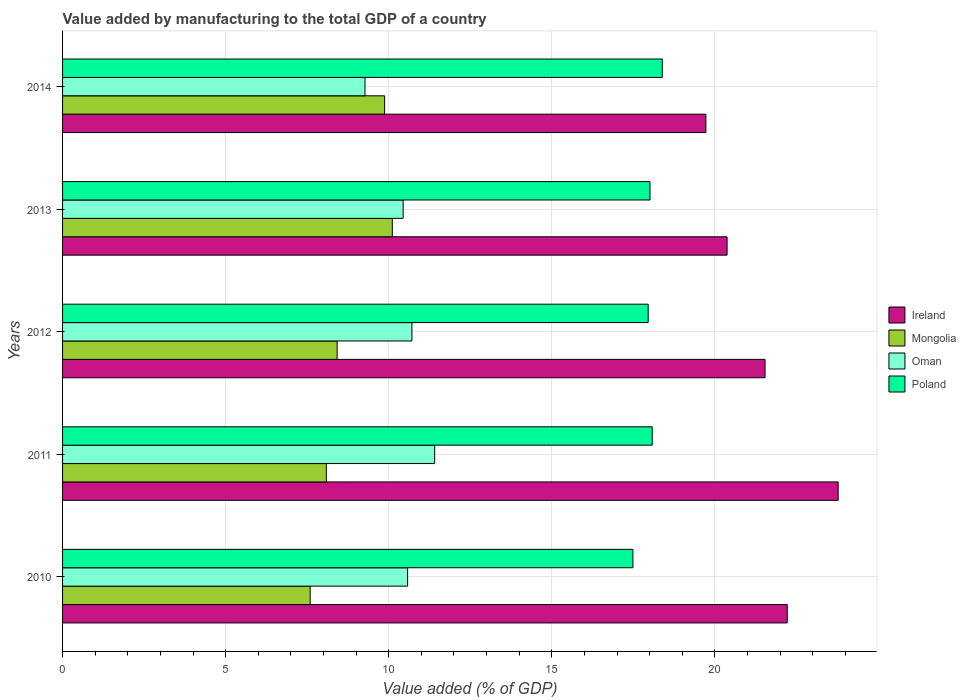How many different coloured bars are there?
Offer a very short reply. 4. How many groups of bars are there?
Keep it short and to the point. 5. Are the number of bars per tick equal to the number of legend labels?
Provide a short and direct response. Yes. Are the number of bars on each tick of the Y-axis equal?
Provide a succinct answer. Yes. How many bars are there on the 5th tick from the top?
Provide a succinct answer. 4. How many bars are there on the 5th tick from the bottom?
Give a very brief answer. 4. What is the value added by manufacturing to the total GDP in Oman in 2014?
Your answer should be very brief. 9.27. Across all years, what is the maximum value added by manufacturing to the total GDP in Oman?
Provide a succinct answer. 11.41. Across all years, what is the minimum value added by manufacturing to the total GDP in Ireland?
Your answer should be compact. 19.72. In which year was the value added by manufacturing to the total GDP in Ireland maximum?
Ensure brevity in your answer.  2011. What is the total value added by manufacturing to the total GDP in Oman in the graph?
Give a very brief answer. 52.41. What is the difference between the value added by manufacturing to the total GDP in Mongolia in 2012 and that in 2013?
Provide a short and direct response. -1.69. What is the difference between the value added by manufacturing to the total GDP in Mongolia in 2014 and the value added by manufacturing to the total GDP in Oman in 2013?
Make the answer very short. -0.57. What is the average value added by manufacturing to the total GDP in Poland per year?
Your answer should be compact. 17.98. In the year 2012, what is the difference between the value added by manufacturing to the total GDP in Poland and value added by manufacturing to the total GDP in Ireland?
Your response must be concise. -3.58. In how many years, is the value added by manufacturing to the total GDP in Oman greater than 15 %?
Offer a terse response. 0. What is the ratio of the value added by manufacturing to the total GDP in Oman in 2012 to that in 2014?
Offer a very short reply. 1.16. Is the difference between the value added by manufacturing to the total GDP in Poland in 2012 and 2013 greater than the difference between the value added by manufacturing to the total GDP in Ireland in 2012 and 2013?
Keep it short and to the point. No. What is the difference between the highest and the second highest value added by manufacturing to the total GDP in Oman?
Give a very brief answer. 0.7. What is the difference between the highest and the lowest value added by manufacturing to the total GDP in Ireland?
Provide a short and direct response. 4.06. Is the sum of the value added by manufacturing to the total GDP in Mongolia in 2012 and 2013 greater than the maximum value added by manufacturing to the total GDP in Ireland across all years?
Your answer should be very brief. No. Is it the case that in every year, the sum of the value added by manufacturing to the total GDP in Mongolia and value added by manufacturing to the total GDP in Poland is greater than the sum of value added by manufacturing to the total GDP in Oman and value added by manufacturing to the total GDP in Ireland?
Make the answer very short. No. What does the 3rd bar from the top in 2013 represents?
Give a very brief answer. Mongolia. What does the 1st bar from the bottom in 2014 represents?
Your answer should be very brief. Ireland. Is it the case that in every year, the sum of the value added by manufacturing to the total GDP in Poland and value added by manufacturing to the total GDP in Oman is greater than the value added by manufacturing to the total GDP in Ireland?
Offer a terse response. Yes. How many bars are there?
Offer a terse response. 20. Are the values on the major ticks of X-axis written in scientific E-notation?
Keep it short and to the point. No. How are the legend labels stacked?
Make the answer very short. Vertical. What is the title of the graph?
Your answer should be compact. Value added by manufacturing to the total GDP of a country. Does "Costa Rica" appear as one of the legend labels in the graph?
Keep it short and to the point. No. What is the label or title of the X-axis?
Make the answer very short. Value added (% of GDP). What is the Value added (% of GDP) in Ireland in 2010?
Ensure brevity in your answer.  22.22. What is the Value added (% of GDP) in Mongolia in 2010?
Offer a terse response. 7.59. What is the Value added (% of GDP) of Oman in 2010?
Make the answer very short. 10.58. What is the Value added (% of GDP) of Poland in 2010?
Your answer should be compact. 17.49. What is the Value added (% of GDP) of Ireland in 2011?
Provide a short and direct response. 23.78. What is the Value added (% of GDP) of Mongolia in 2011?
Ensure brevity in your answer.  8.09. What is the Value added (% of GDP) of Oman in 2011?
Ensure brevity in your answer.  11.41. What is the Value added (% of GDP) in Poland in 2011?
Your answer should be compact. 18.08. What is the Value added (% of GDP) of Ireland in 2012?
Give a very brief answer. 21.54. What is the Value added (% of GDP) of Mongolia in 2012?
Make the answer very short. 8.42. What is the Value added (% of GDP) in Oman in 2012?
Provide a succinct answer. 10.71. What is the Value added (% of GDP) in Poland in 2012?
Make the answer very short. 17.95. What is the Value added (% of GDP) of Ireland in 2013?
Provide a succinct answer. 20.37. What is the Value added (% of GDP) in Mongolia in 2013?
Provide a succinct answer. 10.11. What is the Value added (% of GDP) of Oman in 2013?
Provide a short and direct response. 10.44. What is the Value added (% of GDP) in Poland in 2013?
Give a very brief answer. 18.01. What is the Value added (% of GDP) of Ireland in 2014?
Offer a terse response. 19.72. What is the Value added (% of GDP) of Mongolia in 2014?
Your answer should be compact. 9.87. What is the Value added (% of GDP) in Oman in 2014?
Offer a terse response. 9.27. What is the Value added (% of GDP) of Poland in 2014?
Your response must be concise. 18.39. Across all years, what is the maximum Value added (% of GDP) in Ireland?
Provide a short and direct response. 23.78. Across all years, what is the maximum Value added (% of GDP) in Mongolia?
Keep it short and to the point. 10.11. Across all years, what is the maximum Value added (% of GDP) of Oman?
Ensure brevity in your answer.  11.41. Across all years, what is the maximum Value added (% of GDP) in Poland?
Your answer should be compact. 18.39. Across all years, what is the minimum Value added (% of GDP) in Ireland?
Provide a short and direct response. 19.72. Across all years, what is the minimum Value added (% of GDP) in Mongolia?
Provide a succinct answer. 7.59. Across all years, what is the minimum Value added (% of GDP) of Oman?
Offer a terse response. 9.27. Across all years, what is the minimum Value added (% of GDP) in Poland?
Offer a very short reply. 17.49. What is the total Value added (% of GDP) of Ireland in the graph?
Make the answer very short. 107.63. What is the total Value added (% of GDP) of Mongolia in the graph?
Keep it short and to the point. 44.08. What is the total Value added (% of GDP) of Oman in the graph?
Ensure brevity in your answer.  52.41. What is the total Value added (% of GDP) of Poland in the graph?
Ensure brevity in your answer.  89.91. What is the difference between the Value added (% of GDP) in Ireland in 2010 and that in 2011?
Offer a terse response. -1.56. What is the difference between the Value added (% of GDP) in Mongolia in 2010 and that in 2011?
Your response must be concise. -0.5. What is the difference between the Value added (% of GDP) of Oman in 2010 and that in 2011?
Your response must be concise. -0.83. What is the difference between the Value added (% of GDP) in Poland in 2010 and that in 2011?
Offer a terse response. -0.59. What is the difference between the Value added (% of GDP) of Ireland in 2010 and that in 2012?
Ensure brevity in your answer.  0.68. What is the difference between the Value added (% of GDP) of Mongolia in 2010 and that in 2012?
Your answer should be very brief. -0.83. What is the difference between the Value added (% of GDP) of Oman in 2010 and that in 2012?
Ensure brevity in your answer.  -0.13. What is the difference between the Value added (% of GDP) in Poland in 2010 and that in 2012?
Make the answer very short. -0.47. What is the difference between the Value added (% of GDP) in Ireland in 2010 and that in 2013?
Provide a succinct answer. 1.84. What is the difference between the Value added (% of GDP) of Mongolia in 2010 and that in 2013?
Provide a succinct answer. -2.52. What is the difference between the Value added (% of GDP) of Oman in 2010 and that in 2013?
Keep it short and to the point. 0.14. What is the difference between the Value added (% of GDP) of Poland in 2010 and that in 2013?
Make the answer very short. -0.52. What is the difference between the Value added (% of GDP) of Ireland in 2010 and that in 2014?
Offer a very short reply. 2.5. What is the difference between the Value added (% of GDP) of Mongolia in 2010 and that in 2014?
Offer a terse response. -2.28. What is the difference between the Value added (% of GDP) in Oman in 2010 and that in 2014?
Ensure brevity in your answer.  1.31. What is the difference between the Value added (% of GDP) in Ireland in 2011 and that in 2012?
Provide a succinct answer. 2.24. What is the difference between the Value added (% of GDP) in Mongolia in 2011 and that in 2012?
Give a very brief answer. -0.33. What is the difference between the Value added (% of GDP) of Oman in 2011 and that in 2012?
Make the answer very short. 0.7. What is the difference between the Value added (% of GDP) of Poland in 2011 and that in 2012?
Your answer should be very brief. 0.12. What is the difference between the Value added (% of GDP) of Ireland in 2011 and that in 2013?
Keep it short and to the point. 3.4. What is the difference between the Value added (% of GDP) of Mongolia in 2011 and that in 2013?
Offer a very short reply. -2.02. What is the difference between the Value added (% of GDP) of Oman in 2011 and that in 2013?
Keep it short and to the point. 0.97. What is the difference between the Value added (% of GDP) in Poland in 2011 and that in 2013?
Ensure brevity in your answer.  0.07. What is the difference between the Value added (% of GDP) in Ireland in 2011 and that in 2014?
Ensure brevity in your answer.  4.06. What is the difference between the Value added (% of GDP) in Mongolia in 2011 and that in 2014?
Give a very brief answer. -1.79. What is the difference between the Value added (% of GDP) in Oman in 2011 and that in 2014?
Your answer should be very brief. 2.14. What is the difference between the Value added (% of GDP) of Poland in 2011 and that in 2014?
Ensure brevity in your answer.  -0.31. What is the difference between the Value added (% of GDP) of Ireland in 2012 and that in 2013?
Offer a very short reply. 1.16. What is the difference between the Value added (% of GDP) in Mongolia in 2012 and that in 2013?
Give a very brief answer. -1.69. What is the difference between the Value added (% of GDP) of Oman in 2012 and that in 2013?
Provide a short and direct response. 0.27. What is the difference between the Value added (% of GDP) of Poland in 2012 and that in 2013?
Offer a terse response. -0.06. What is the difference between the Value added (% of GDP) of Ireland in 2012 and that in 2014?
Ensure brevity in your answer.  1.82. What is the difference between the Value added (% of GDP) in Mongolia in 2012 and that in 2014?
Provide a short and direct response. -1.46. What is the difference between the Value added (% of GDP) in Oman in 2012 and that in 2014?
Make the answer very short. 1.44. What is the difference between the Value added (% of GDP) of Poland in 2012 and that in 2014?
Give a very brief answer. -0.43. What is the difference between the Value added (% of GDP) of Ireland in 2013 and that in 2014?
Offer a terse response. 0.65. What is the difference between the Value added (% of GDP) of Mongolia in 2013 and that in 2014?
Provide a short and direct response. 0.24. What is the difference between the Value added (% of GDP) of Oman in 2013 and that in 2014?
Your answer should be very brief. 1.17. What is the difference between the Value added (% of GDP) of Poland in 2013 and that in 2014?
Give a very brief answer. -0.38. What is the difference between the Value added (% of GDP) in Ireland in 2010 and the Value added (% of GDP) in Mongolia in 2011?
Provide a succinct answer. 14.13. What is the difference between the Value added (% of GDP) in Ireland in 2010 and the Value added (% of GDP) in Oman in 2011?
Give a very brief answer. 10.81. What is the difference between the Value added (% of GDP) in Ireland in 2010 and the Value added (% of GDP) in Poland in 2011?
Ensure brevity in your answer.  4.14. What is the difference between the Value added (% of GDP) in Mongolia in 2010 and the Value added (% of GDP) in Oman in 2011?
Give a very brief answer. -3.82. What is the difference between the Value added (% of GDP) of Mongolia in 2010 and the Value added (% of GDP) of Poland in 2011?
Your answer should be very brief. -10.49. What is the difference between the Value added (% of GDP) of Oman in 2010 and the Value added (% of GDP) of Poland in 2011?
Provide a short and direct response. -7.5. What is the difference between the Value added (% of GDP) of Ireland in 2010 and the Value added (% of GDP) of Mongolia in 2012?
Offer a terse response. 13.8. What is the difference between the Value added (% of GDP) of Ireland in 2010 and the Value added (% of GDP) of Oman in 2012?
Your answer should be very brief. 11.51. What is the difference between the Value added (% of GDP) of Ireland in 2010 and the Value added (% of GDP) of Poland in 2012?
Offer a terse response. 4.26. What is the difference between the Value added (% of GDP) of Mongolia in 2010 and the Value added (% of GDP) of Oman in 2012?
Provide a succinct answer. -3.12. What is the difference between the Value added (% of GDP) of Mongolia in 2010 and the Value added (% of GDP) of Poland in 2012?
Provide a succinct answer. -10.36. What is the difference between the Value added (% of GDP) in Oman in 2010 and the Value added (% of GDP) in Poland in 2012?
Provide a succinct answer. -7.38. What is the difference between the Value added (% of GDP) of Ireland in 2010 and the Value added (% of GDP) of Mongolia in 2013?
Your response must be concise. 12.11. What is the difference between the Value added (% of GDP) in Ireland in 2010 and the Value added (% of GDP) in Oman in 2013?
Offer a very short reply. 11.78. What is the difference between the Value added (% of GDP) in Ireland in 2010 and the Value added (% of GDP) in Poland in 2013?
Offer a terse response. 4.21. What is the difference between the Value added (% of GDP) in Mongolia in 2010 and the Value added (% of GDP) in Oman in 2013?
Make the answer very short. -2.85. What is the difference between the Value added (% of GDP) of Mongolia in 2010 and the Value added (% of GDP) of Poland in 2013?
Ensure brevity in your answer.  -10.42. What is the difference between the Value added (% of GDP) in Oman in 2010 and the Value added (% of GDP) in Poland in 2013?
Your response must be concise. -7.43. What is the difference between the Value added (% of GDP) in Ireland in 2010 and the Value added (% of GDP) in Mongolia in 2014?
Your response must be concise. 12.34. What is the difference between the Value added (% of GDP) of Ireland in 2010 and the Value added (% of GDP) of Oman in 2014?
Your response must be concise. 12.95. What is the difference between the Value added (% of GDP) of Ireland in 2010 and the Value added (% of GDP) of Poland in 2014?
Provide a succinct answer. 3.83. What is the difference between the Value added (% of GDP) in Mongolia in 2010 and the Value added (% of GDP) in Oman in 2014?
Your answer should be compact. -1.68. What is the difference between the Value added (% of GDP) of Mongolia in 2010 and the Value added (% of GDP) of Poland in 2014?
Ensure brevity in your answer.  -10.8. What is the difference between the Value added (% of GDP) of Oman in 2010 and the Value added (% of GDP) of Poland in 2014?
Make the answer very short. -7.81. What is the difference between the Value added (% of GDP) in Ireland in 2011 and the Value added (% of GDP) in Mongolia in 2012?
Give a very brief answer. 15.36. What is the difference between the Value added (% of GDP) of Ireland in 2011 and the Value added (% of GDP) of Oman in 2012?
Your response must be concise. 13.07. What is the difference between the Value added (% of GDP) of Ireland in 2011 and the Value added (% of GDP) of Poland in 2012?
Offer a terse response. 5.82. What is the difference between the Value added (% of GDP) of Mongolia in 2011 and the Value added (% of GDP) of Oman in 2012?
Make the answer very short. -2.62. What is the difference between the Value added (% of GDP) in Mongolia in 2011 and the Value added (% of GDP) in Poland in 2012?
Offer a very short reply. -9.87. What is the difference between the Value added (% of GDP) of Oman in 2011 and the Value added (% of GDP) of Poland in 2012?
Ensure brevity in your answer.  -6.55. What is the difference between the Value added (% of GDP) in Ireland in 2011 and the Value added (% of GDP) in Mongolia in 2013?
Provide a succinct answer. 13.67. What is the difference between the Value added (% of GDP) in Ireland in 2011 and the Value added (% of GDP) in Oman in 2013?
Make the answer very short. 13.34. What is the difference between the Value added (% of GDP) in Ireland in 2011 and the Value added (% of GDP) in Poland in 2013?
Ensure brevity in your answer.  5.77. What is the difference between the Value added (% of GDP) of Mongolia in 2011 and the Value added (% of GDP) of Oman in 2013?
Keep it short and to the point. -2.36. What is the difference between the Value added (% of GDP) of Mongolia in 2011 and the Value added (% of GDP) of Poland in 2013?
Make the answer very short. -9.92. What is the difference between the Value added (% of GDP) of Oman in 2011 and the Value added (% of GDP) of Poland in 2013?
Make the answer very short. -6.6. What is the difference between the Value added (% of GDP) in Ireland in 2011 and the Value added (% of GDP) in Mongolia in 2014?
Keep it short and to the point. 13.9. What is the difference between the Value added (% of GDP) in Ireland in 2011 and the Value added (% of GDP) in Oman in 2014?
Provide a succinct answer. 14.51. What is the difference between the Value added (% of GDP) of Ireland in 2011 and the Value added (% of GDP) of Poland in 2014?
Give a very brief answer. 5.39. What is the difference between the Value added (% of GDP) of Mongolia in 2011 and the Value added (% of GDP) of Oman in 2014?
Make the answer very short. -1.19. What is the difference between the Value added (% of GDP) in Mongolia in 2011 and the Value added (% of GDP) in Poland in 2014?
Provide a short and direct response. -10.3. What is the difference between the Value added (% of GDP) of Oman in 2011 and the Value added (% of GDP) of Poland in 2014?
Provide a succinct answer. -6.98. What is the difference between the Value added (% of GDP) in Ireland in 2012 and the Value added (% of GDP) in Mongolia in 2013?
Provide a succinct answer. 11.43. What is the difference between the Value added (% of GDP) of Ireland in 2012 and the Value added (% of GDP) of Oman in 2013?
Keep it short and to the point. 11.1. What is the difference between the Value added (% of GDP) of Ireland in 2012 and the Value added (% of GDP) of Poland in 2013?
Ensure brevity in your answer.  3.53. What is the difference between the Value added (% of GDP) in Mongolia in 2012 and the Value added (% of GDP) in Oman in 2013?
Your answer should be compact. -2.02. What is the difference between the Value added (% of GDP) in Mongolia in 2012 and the Value added (% of GDP) in Poland in 2013?
Provide a short and direct response. -9.59. What is the difference between the Value added (% of GDP) of Oman in 2012 and the Value added (% of GDP) of Poland in 2013?
Give a very brief answer. -7.3. What is the difference between the Value added (% of GDP) in Ireland in 2012 and the Value added (% of GDP) in Mongolia in 2014?
Your response must be concise. 11.66. What is the difference between the Value added (% of GDP) in Ireland in 2012 and the Value added (% of GDP) in Oman in 2014?
Provide a succinct answer. 12.27. What is the difference between the Value added (% of GDP) in Ireland in 2012 and the Value added (% of GDP) in Poland in 2014?
Provide a succinct answer. 3.15. What is the difference between the Value added (% of GDP) of Mongolia in 2012 and the Value added (% of GDP) of Oman in 2014?
Ensure brevity in your answer.  -0.85. What is the difference between the Value added (% of GDP) in Mongolia in 2012 and the Value added (% of GDP) in Poland in 2014?
Make the answer very short. -9.97. What is the difference between the Value added (% of GDP) of Oman in 2012 and the Value added (% of GDP) of Poland in 2014?
Keep it short and to the point. -7.68. What is the difference between the Value added (% of GDP) of Ireland in 2013 and the Value added (% of GDP) of Mongolia in 2014?
Give a very brief answer. 10.5. What is the difference between the Value added (% of GDP) in Ireland in 2013 and the Value added (% of GDP) in Oman in 2014?
Provide a short and direct response. 11.1. What is the difference between the Value added (% of GDP) in Ireland in 2013 and the Value added (% of GDP) in Poland in 2014?
Provide a succinct answer. 1.99. What is the difference between the Value added (% of GDP) in Mongolia in 2013 and the Value added (% of GDP) in Oman in 2014?
Your answer should be very brief. 0.84. What is the difference between the Value added (% of GDP) of Mongolia in 2013 and the Value added (% of GDP) of Poland in 2014?
Offer a very short reply. -8.28. What is the difference between the Value added (% of GDP) of Oman in 2013 and the Value added (% of GDP) of Poland in 2014?
Provide a succinct answer. -7.94. What is the average Value added (% of GDP) in Ireland per year?
Keep it short and to the point. 21.53. What is the average Value added (% of GDP) of Mongolia per year?
Provide a succinct answer. 8.82. What is the average Value added (% of GDP) in Oman per year?
Your answer should be compact. 10.48. What is the average Value added (% of GDP) in Poland per year?
Your answer should be compact. 17.98. In the year 2010, what is the difference between the Value added (% of GDP) in Ireland and Value added (% of GDP) in Mongolia?
Provide a succinct answer. 14.63. In the year 2010, what is the difference between the Value added (% of GDP) in Ireland and Value added (% of GDP) in Oman?
Offer a terse response. 11.64. In the year 2010, what is the difference between the Value added (% of GDP) of Ireland and Value added (% of GDP) of Poland?
Offer a very short reply. 4.73. In the year 2010, what is the difference between the Value added (% of GDP) in Mongolia and Value added (% of GDP) in Oman?
Your answer should be compact. -2.99. In the year 2010, what is the difference between the Value added (% of GDP) of Mongolia and Value added (% of GDP) of Poland?
Offer a terse response. -9.9. In the year 2010, what is the difference between the Value added (% of GDP) in Oman and Value added (% of GDP) in Poland?
Your answer should be compact. -6.91. In the year 2011, what is the difference between the Value added (% of GDP) in Ireland and Value added (% of GDP) in Mongolia?
Offer a terse response. 15.69. In the year 2011, what is the difference between the Value added (% of GDP) in Ireland and Value added (% of GDP) in Oman?
Give a very brief answer. 12.37. In the year 2011, what is the difference between the Value added (% of GDP) of Mongolia and Value added (% of GDP) of Oman?
Keep it short and to the point. -3.32. In the year 2011, what is the difference between the Value added (% of GDP) in Mongolia and Value added (% of GDP) in Poland?
Offer a very short reply. -9.99. In the year 2011, what is the difference between the Value added (% of GDP) in Oman and Value added (% of GDP) in Poland?
Your response must be concise. -6.67. In the year 2012, what is the difference between the Value added (% of GDP) in Ireland and Value added (% of GDP) in Mongolia?
Your answer should be very brief. 13.12. In the year 2012, what is the difference between the Value added (% of GDP) in Ireland and Value added (% of GDP) in Oman?
Provide a short and direct response. 10.83. In the year 2012, what is the difference between the Value added (% of GDP) of Ireland and Value added (% of GDP) of Poland?
Give a very brief answer. 3.58. In the year 2012, what is the difference between the Value added (% of GDP) of Mongolia and Value added (% of GDP) of Oman?
Your answer should be compact. -2.29. In the year 2012, what is the difference between the Value added (% of GDP) of Mongolia and Value added (% of GDP) of Poland?
Ensure brevity in your answer.  -9.54. In the year 2012, what is the difference between the Value added (% of GDP) in Oman and Value added (% of GDP) in Poland?
Your response must be concise. -7.24. In the year 2013, what is the difference between the Value added (% of GDP) in Ireland and Value added (% of GDP) in Mongolia?
Your response must be concise. 10.26. In the year 2013, what is the difference between the Value added (% of GDP) in Ireland and Value added (% of GDP) in Oman?
Give a very brief answer. 9.93. In the year 2013, what is the difference between the Value added (% of GDP) of Ireland and Value added (% of GDP) of Poland?
Your response must be concise. 2.36. In the year 2013, what is the difference between the Value added (% of GDP) in Mongolia and Value added (% of GDP) in Oman?
Ensure brevity in your answer.  -0.33. In the year 2013, what is the difference between the Value added (% of GDP) in Mongolia and Value added (% of GDP) in Poland?
Make the answer very short. -7.9. In the year 2013, what is the difference between the Value added (% of GDP) of Oman and Value added (% of GDP) of Poland?
Make the answer very short. -7.57. In the year 2014, what is the difference between the Value added (% of GDP) in Ireland and Value added (% of GDP) in Mongolia?
Keep it short and to the point. 9.85. In the year 2014, what is the difference between the Value added (% of GDP) of Ireland and Value added (% of GDP) of Oman?
Your answer should be very brief. 10.45. In the year 2014, what is the difference between the Value added (% of GDP) in Ireland and Value added (% of GDP) in Poland?
Your answer should be very brief. 1.34. In the year 2014, what is the difference between the Value added (% of GDP) in Mongolia and Value added (% of GDP) in Oman?
Offer a terse response. 0.6. In the year 2014, what is the difference between the Value added (% of GDP) in Mongolia and Value added (% of GDP) in Poland?
Your response must be concise. -8.51. In the year 2014, what is the difference between the Value added (% of GDP) of Oman and Value added (% of GDP) of Poland?
Offer a terse response. -9.11. What is the ratio of the Value added (% of GDP) in Ireland in 2010 to that in 2011?
Ensure brevity in your answer.  0.93. What is the ratio of the Value added (% of GDP) in Mongolia in 2010 to that in 2011?
Your response must be concise. 0.94. What is the ratio of the Value added (% of GDP) in Oman in 2010 to that in 2011?
Give a very brief answer. 0.93. What is the ratio of the Value added (% of GDP) in Poland in 2010 to that in 2011?
Keep it short and to the point. 0.97. What is the ratio of the Value added (% of GDP) in Ireland in 2010 to that in 2012?
Ensure brevity in your answer.  1.03. What is the ratio of the Value added (% of GDP) in Mongolia in 2010 to that in 2012?
Give a very brief answer. 0.9. What is the ratio of the Value added (% of GDP) of Oman in 2010 to that in 2012?
Give a very brief answer. 0.99. What is the ratio of the Value added (% of GDP) in Poland in 2010 to that in 2012?
Make the answer very short. 0.97. What is the ratio of the Value added (% of GDP) in Ireland in 2010 to that in 2013?
Offer a terse response. 1.09. What is the ratio of the Value added (% of GDP) in Mongolia in 2010 to that in 2013?
Provide a short and direct response. 0.75. What is the ratio of the Value added (% of GDP) in Oman in 2010 to that in 2013?
Provide a short and direct response. 1.01. What is the ratio of the Value added (% of GDP) in Poland in 2010 to that in 2013?
Make the answer very short. 0.97. What is the ratio of the Value added (% of GDP) in Ireland in 2010 to that in 2014?
Make the answer very short. 1.13. What is the ratio of the Value added (% of GDP) in Mongolia in 2010 to that in 2014?
Give a very brief answer. 0.77. What is the ratio of the Value added (% of GDP) of Oman in 2010 to that in 2014?
Your response must be concise. 1.14. What is the ratio of the Value added (% of GDP) of Poland in 2010 to that in 2014?
Your response must be concise. 0.95. What is the ratio of the Value added (% of GDP) of Ireland in 2011 to that in 2012?
Offer a terse response. 1.1. What is the ratio of the Value added (% of GDP) in Mongolia in 2011 to that in 2012?
Make the answer very short. 0.96. What is the ratio of the Value added (% of GDP) in Oman in 2011 to that in 2012?
Your answer should be compact. 1.07. What is the ratio of the Value added (% of GDP) in Ireland in 2011 to that in 2013?
Offer a very short reply. 1.17. What is the ratio of the Value added (% of GDP) in Mongolia in 2011 to that in 2013?
Offer a terse response. 0.8. What is the ratio of the Value added (% of GDP) in Oman in 2011 to that in 2013?
Give a very brief answer. 1.09. What is the ratio of the Value added (% of GDP) in Poland in 2011 to that in 2013?
Offer a very short reply. 1. What is the ratio of the Value added (% of GDP) in Ireland in 2011 to that in 2014?
Your response must be concise. 1.21. What is the ratio of the Value added (% of GDP) of Mongolia in 2011 to that in 2014?
Your answer should be very brief. 0.82. What is the ratio of the Value added (% of GDP) of Oman in 2011 to that in 2014?
Your response must be concise. 1.23. What is the ratio of the Value added (% of GDP) in Poland in 2011 to that in 2014?
Offer a terse response. 0.98. What is the ratio of the Value added (% of GDP) in Ireland in 2012 to that in 2013?
Keep it short and to the point. 1.06. What is the ratio of the Value added (% of GDP) of Mongolia in 2012 to that in 2013?
Make the answer very short. 0.83. What is the ratio of the Value added (% of GDP) in Oman in 2012 to that in 2013?
Make the answer very short. 1.03. What is the ratio of the Value added (% of GDP) in Ireland in 2012 to that in 2014?
Your response must be concise. 1.09. What is the ratio of the Value added (% of GDP) of Mongolia in 2012 to that in 2014?
Provide a succinct answer. 0.85. What is the ratio of the Value added (% of GDP) of Oman in 2012 to that in 2014?
Your answer should be very brief. 1.16. What is the ratio of the Value added (% of GDP) of Poland in 2012 to that in 2014?
Provide a succinct answer. 0.98. What is the ratio of the Value added (% of GDP) of Ireland in 2013 to that in 2014?
Ensure brevity in your answer.  1.03. What is the ratio of the Value added (% of GDP) in Mongolia in 2013 to that in 2014?
Your answer should be very brief. 1.02. What is the ratio of the Value added (% of GDP) of Oman in 2013 to that in 2014?
Ensure brevity in your answer.  1.13. What is the ratio of the Value added (% of GDP) in Poland in 2013 to that in 2014?
Offer a very short reply. 0.98. What is the difference between the highest and the second highest Value added (% of GDP) in Ireland?
Keep it short and to the point. 1.56. What is the difference between the highest and the second highest Value added (% of GDP) of Mongolia?
Provide a short and direct response. 0.24. What is the difference between the highest and the second highest Value added (% of GDP) of Oman?
Your answer should be very brief. 0.7. What is the difference between the highest and the second highest Value added (% of GDP) of Poland?
Provide a succinct answer. 0.31. What is the difference between the highest and the lowest Value added (% of GDP) in Ireland?
Keep it short and to the point. 4.06. What is the difference between the highest and the lowest Value added (% of GDP) of Mongolia?
Give a very brief answer. 2.52. What is the difference between the highest and the lowest Value added (% of GDP) of Oman?
Your answer should be very brief. 2.14. 